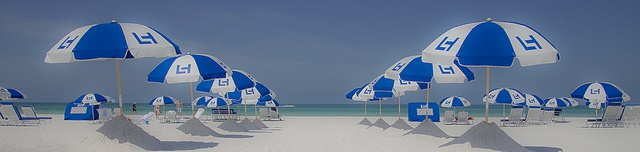Describe the objects in this image and their specific colors. I can see umbrella in blue, darkgray, darkblue, and gray tones, umbrella in blue, darkgray, darkblue, and gray tones, umbrella in blue, darkgray, darkblue, and lightgray tones, umbrella in blue, darkgray, darkblue, and lightgray tones, and umbrella in blue, darkgray, gray, and darkblue tones in this image. 